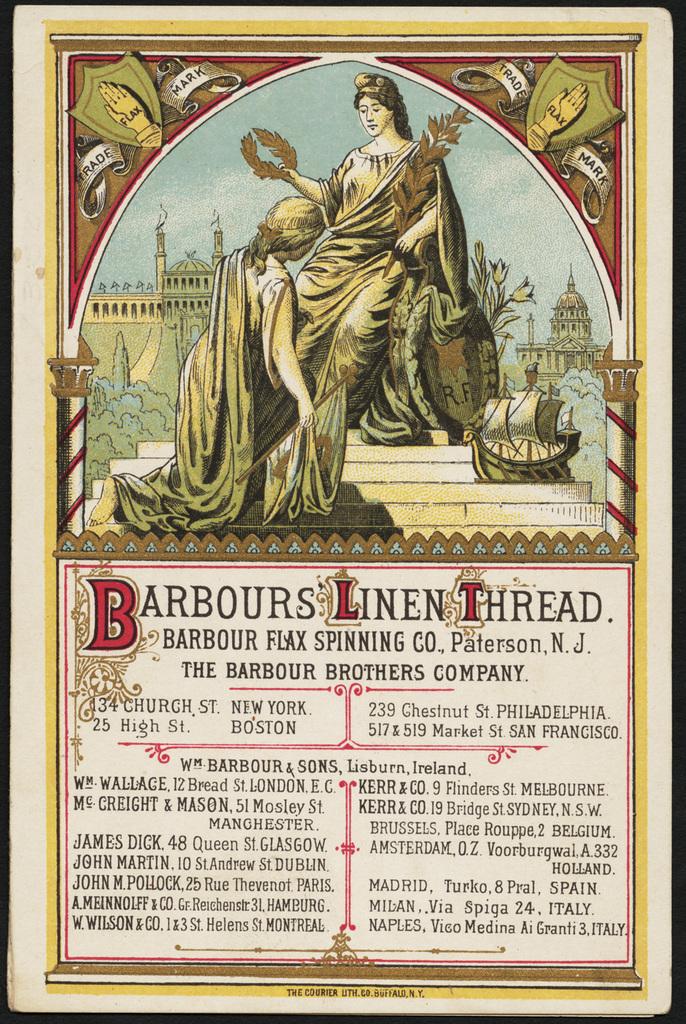What is the title of the publication?
Your answer should be compact. Barbours linen thread. 